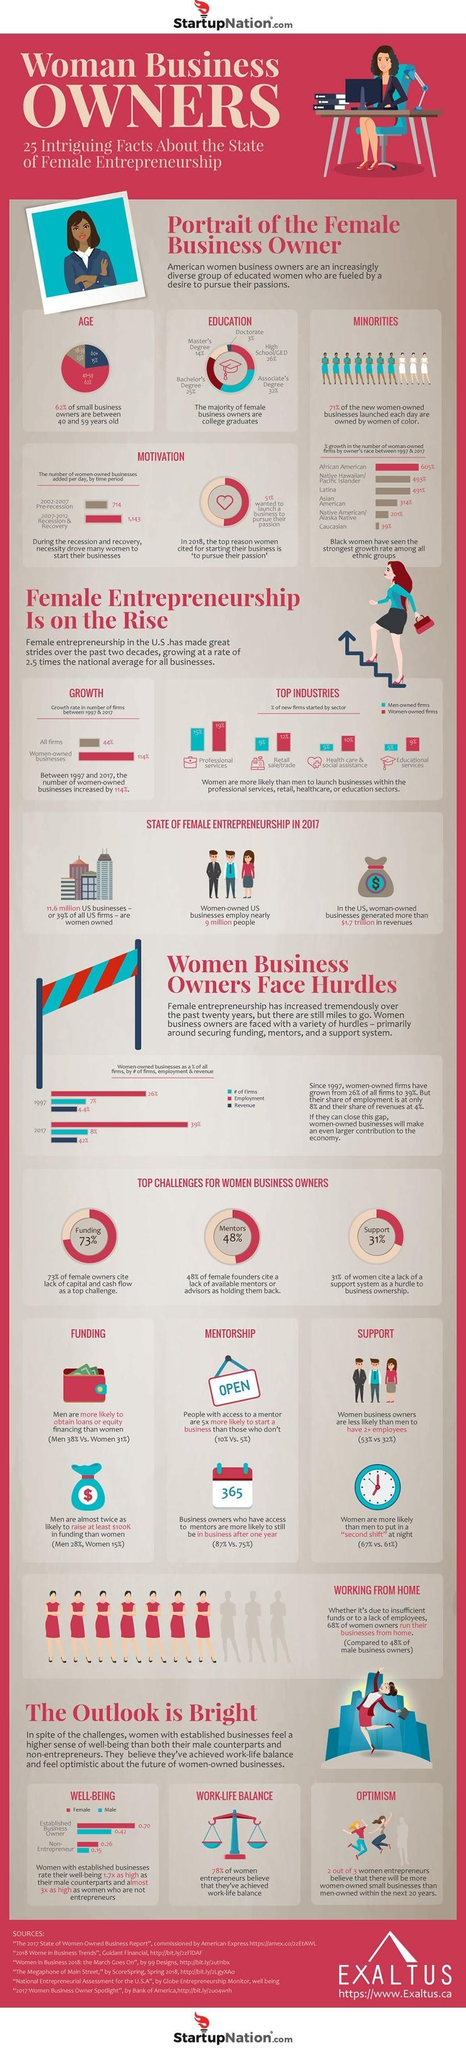Indicate a few pertinent items in this graphic. A significant percentage of business owners are graduates, with figures ranging from 25% to 32%. According to the data, 48% of women cite lack of access to mentorship as a hurdle, while 73% and 31% respectively cite the same. The professional services industry has the highest percentage of women-owned firms. A recent survey has revealed that 15% of small business owners are senior citizens. According to the data, the rate of well-being among non-entrepreneurial women is 0.26. 